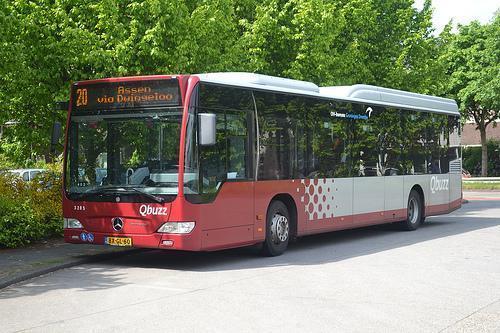How many bus are parked?
Give a very brief answer. 1. 